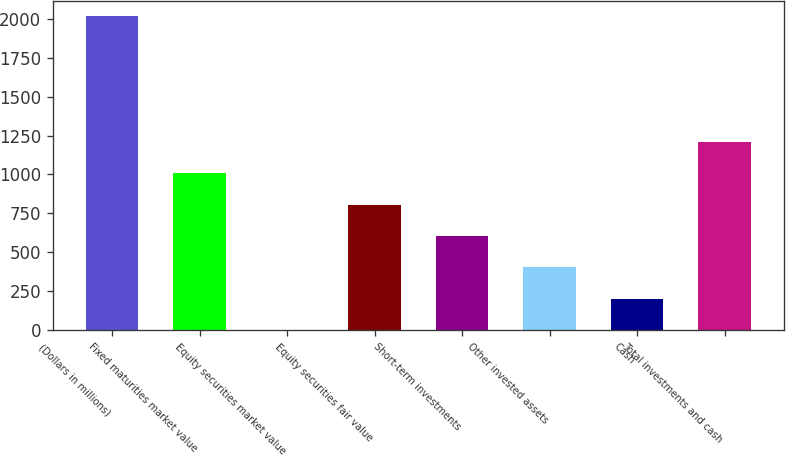<chart> <loc_0><loc_0><loc_500><loc_500><bar_chart><fcel>(Dollars in millions)<fcel>Fixed maturities market value<fcel>Equity securities market value<fcel>Equity securities fair value<fcel>Short-term investments<fcel>Other invested assets<fcel>Cash<fcel>Total investments and cash<nl><fcel>2015<fcel>1007.85<fcel>0.7<fcel>806.42<fcel>604.99<fcel>403.56<fcel>202.13<fcel>1209.28<nl></chart> 